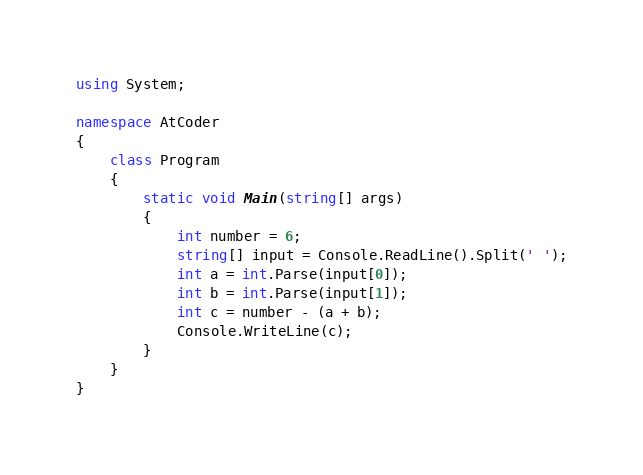<code> <loc_0><loc_0><loc_500><loc_500><_C#_>using System;

namespace AtCoder
{
    class Program
    {
        static void Main(string[] args)
        {
            int number = 6;
            string[] input = Console.ReadLine().Split(' ');
            int a = int.Parse(input[0]);
            int b = int.Parse(input[1]);
            int c = number - (a + b);
            Console.WriteLine(c);
        }
    }
}
</code> 